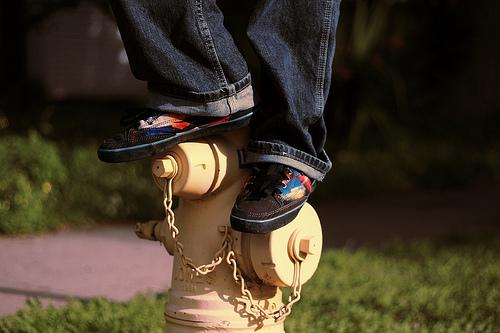Question: what is in the picture?
Choices:
A. A dog.
B. A stop sign.
C. A garbage bin.
D. A fire hydrant.
Answer with the letter. Answer: D Question: when was the picture taken of the boy?
Choices:
A. 10:15 pm.
B. 11:00 pm.
C. Daytime.
D. Midnight.
Answer with the letter. Answer: C Question: what is covering the ground beside the sidewalk?
Choices:
A. Sand.
B. Snow.
C. Grass.
D. Tile.
Answer with the letter. Answer: C Question: how many people are in the picture?
Choices:
A. One.
B. Two.
C. Three.
D. Five.
Answer with the letter. Answer: A Question: who is in the picture?
Choices:
A. A little girl.
B. A grown man.
C. An old woman.
D. A boy.
Answer with the letter. Answer: D 